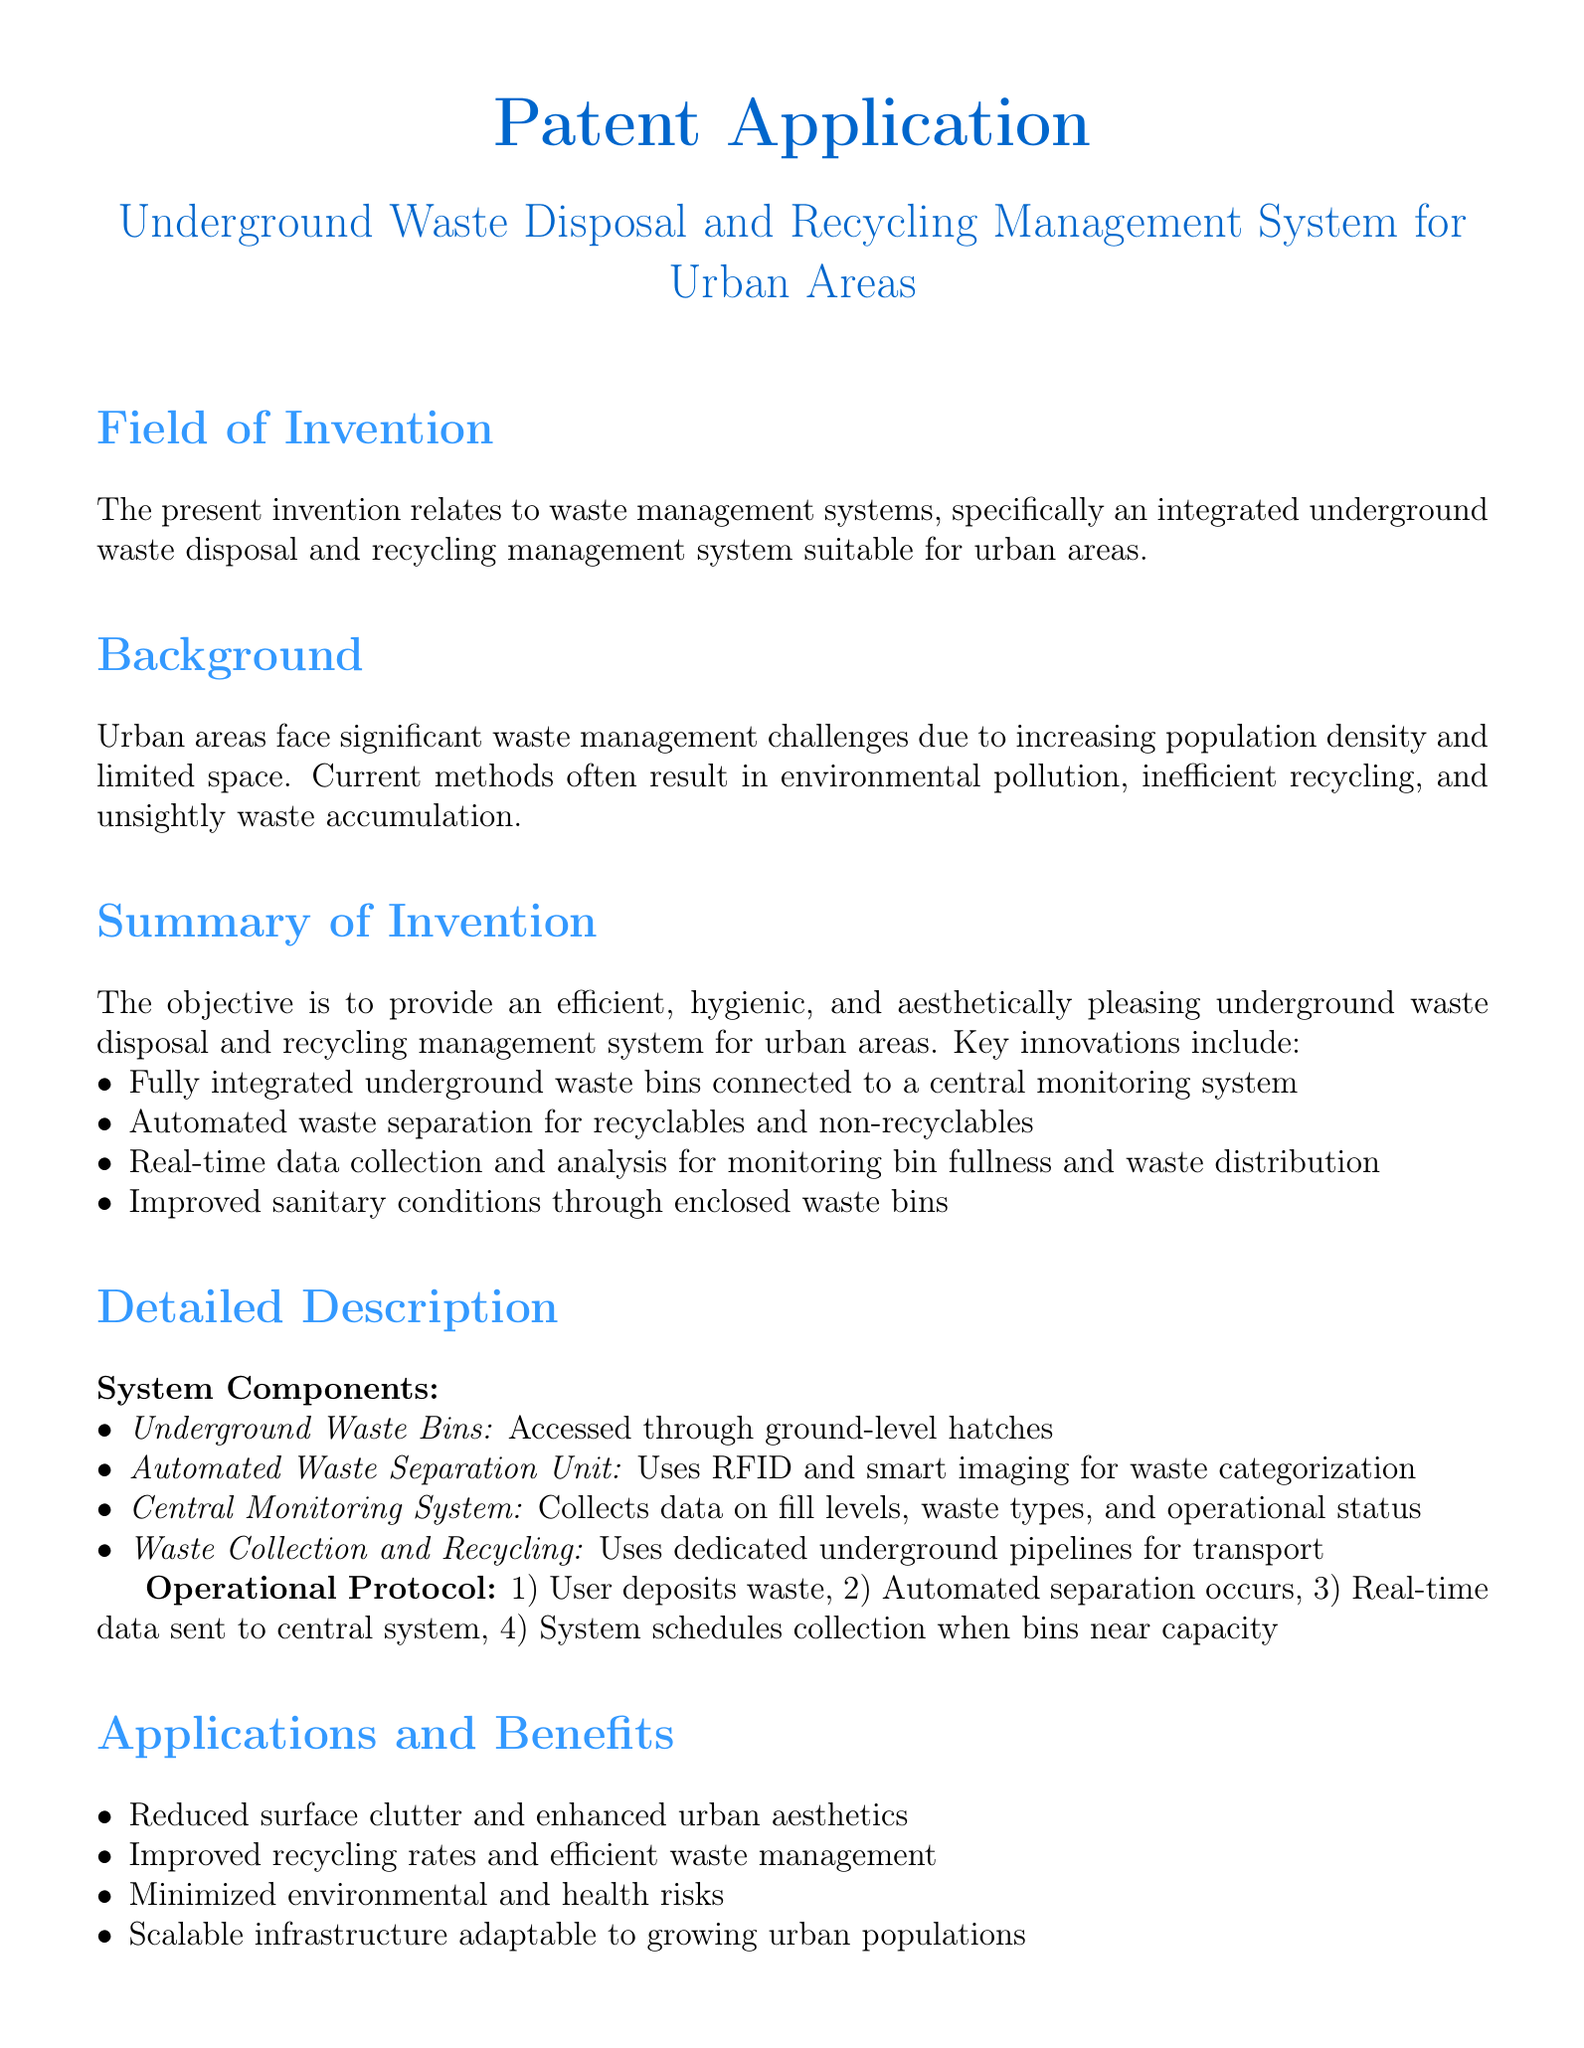What is the title of the invention? The title is explicitly mentioned in the document as "Underground Waste Disposal and Recycling Management System for Urban Areas."
Answer: Underground Waste Disposal and Recycling Management System for Urban Areas What are the key innovations of the system? The document lists key innovations, including fully integrated underground waste bins and automated waste separation.
Answer: Fully integrated underground waste bins, automated waste separation What is the purpose of the central monitoring system? The central monitoring system's function is outlined to collect data on fill levels, waste types, and operational status.
Answer: Collects data on fill levels, waste types, and operational status How does waste separation occur? Automated separation occurs using RFID and smart imaging technology as detailed in the document.
Answer: RFID and smart imaging What is one application of the system? The document mentions reduced surface clutter as one application and benefit of the system.
Answer: Reduced surface clutter What are the system components? The document identifies components such as underground waste bins and an automated waste separation unit.
Answer: Underground waste bins, automated waste separation unit What does the operational protocol begin with? The first step of the operational protocol is the user depositing waste as outlined in the document.
Answer: User deposits waste What is a claimed feature of the waste bins? The document claims that the waste bins include ground-level access hatches and real-time monitoring sensors.
Answer: Ground-level access hatches and real-time monitoring sensors How does the system improve recycling? The system improves recycling rates through automated waste separation as specified in the document.
Answer: Automated waste separation 